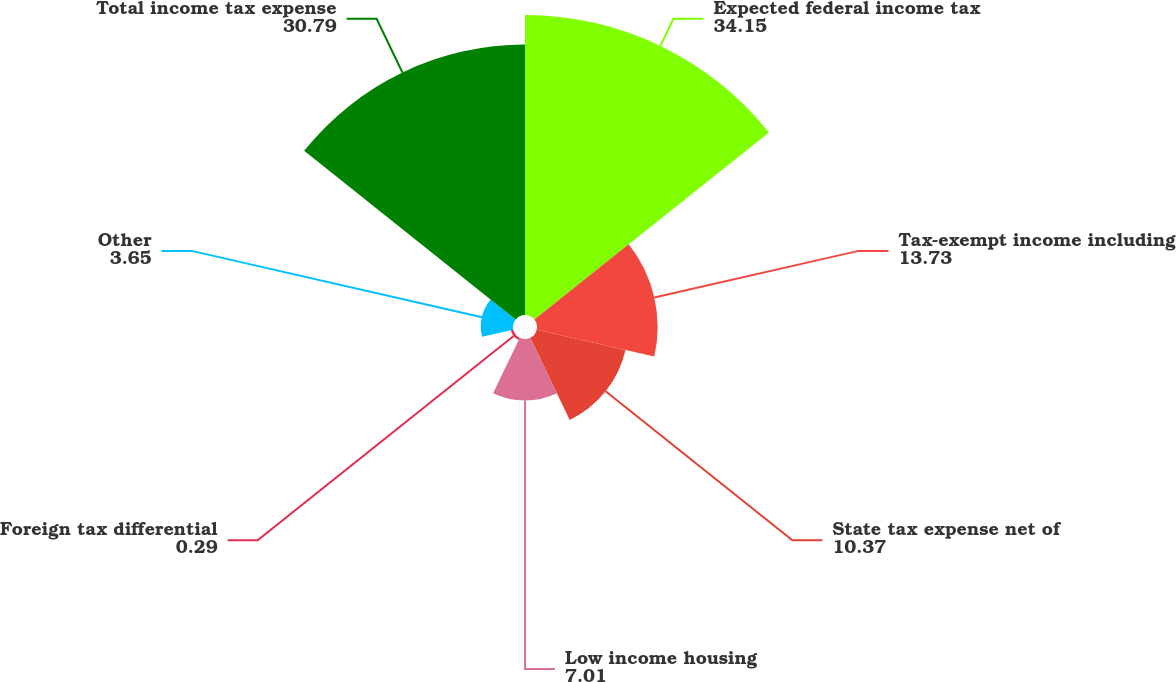Convert chart to OTSL. <chart><loc_0><loc_0><loc_500><loc_500><pie_chart><fcel>Expected federal income tax<fcel>Tax-exempt income including<fcel>State tax expense net of<fcel>Low income housing<fcel>Foreign tax differential<fcel>Other<fcel>Total income tax expense<nl><fcel>34.15%<fcel>13.73%<fcel>10.37%<fcel>7.01%<fcel>0.29%<fcel>3.65%<fcel>30.79%<nl></chart> 